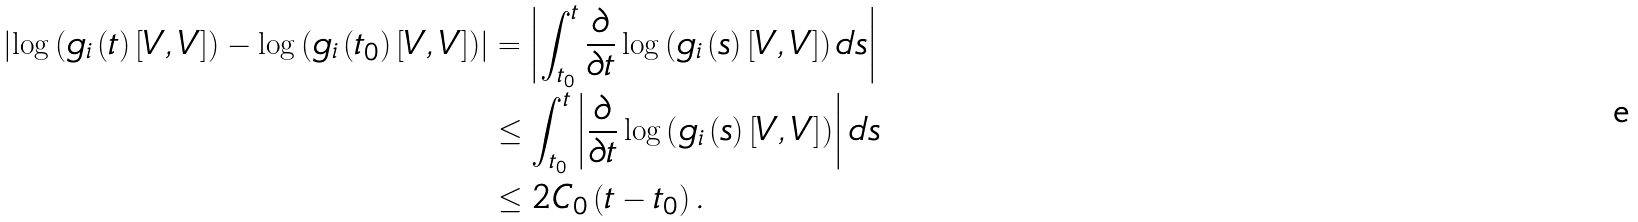<formula> <loc_0><loc_0><loc_500><loc_500>\left | \log \left ( g _ { i } \left ( t \right ) \left [ V , V \right ] \right ) - \log \left ( g _ { i } \left ( t _ { 0 } \right ) \left [ V , V \right ] \right ) \right | & = \left | \int _ { t _ { 0 } } ^ { t } \frac { \partial } { \partial t } \log \left ( g _ { i } \left ( s \right ) \left [ V , V \right ] \right ) d s \right | \\ & \leq \int _ { t _ { 0 } } ^ { t } \left | \frac { \partial } { \partial t } \log \left ( g _ { i } \left ( s \right ) \left [ V , V \right ] \right ) \right | d s \\ & \leq 2 C _ { 0 } \left ( t - t _ { 0 } \right ) .</formula> 